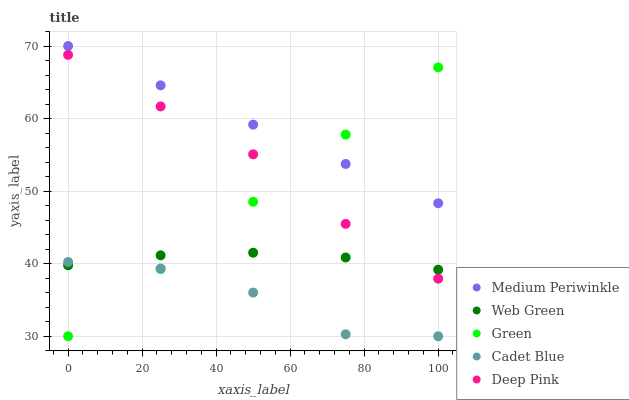Does Cadet Blue have the minimum area under the curve?
Answer yes or no. Yes. Does Medium Periwinkle have the maximum area under the curve?
Answer yes or no. Yes. Does Medium Periwinkle have the minimum area under the curve?
Answer yes or no. No. Does Cadet Blue have the maximum area under the curve?
Answer yes or no. No. Is Green the smoothest?
Answer yes or no. Yes. Is Cadet Blue the roughest?
Answer yes or no. Yes. Is Medium Periwinkle the smoothest?
Answer yes or no. No. Is Medium Periwinkle the roughest?
Answer yes or no. No. Does Green have the lowest value?
Answer yes or no. Yes. Does Medium Periwinkle have the lowest value?
Answer yes or no. No. Does Medium Periwinkle have the highest value?
Answer yes or no. Yes. Does Cadet Blue have the highest value?
Answer yes or no. No. Is Web Green less than Medium Periwinkle?
Answer yes or no. Yes. Is Medium Periwinkle greater than Web Green?
Answer yes or no. Yes. Does Web Green intersect Cadet Blue?
Answer yes or no. Yes. Is Web Green less than Cadet Blue?
Answer yes or no. No. Is Web Green greater than Cadet Blue?
Answer yes or no. No. Does Web Green intersect Medium Periwinkle?
Answer yes or no. No. 